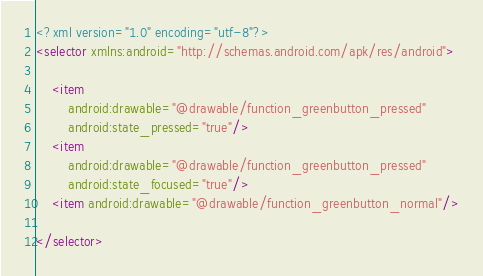Convert code to text. <code><loc_0><loc_0><loc_500><loc_500><_XML_><?xml version="1.0" encoding="utf-8"?>
<selector xmlns:android="http://schemas.android.com/apk/res/android">

    <item
        android:drawable="@drawable/function_greenbutton_pressed"
        android:state_pressed="true"/>
    <item
        android:drawable="@drawable/function_greenbutton_pressed"
        android:state_focused="true"/>
    <item android:drawable="@drawable/function_greenbutton_normal"/>

</selector></code> 